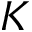Convert formula to latex. <formula><loc_0><loc_0><loc_500><loc_500>K</formula> 